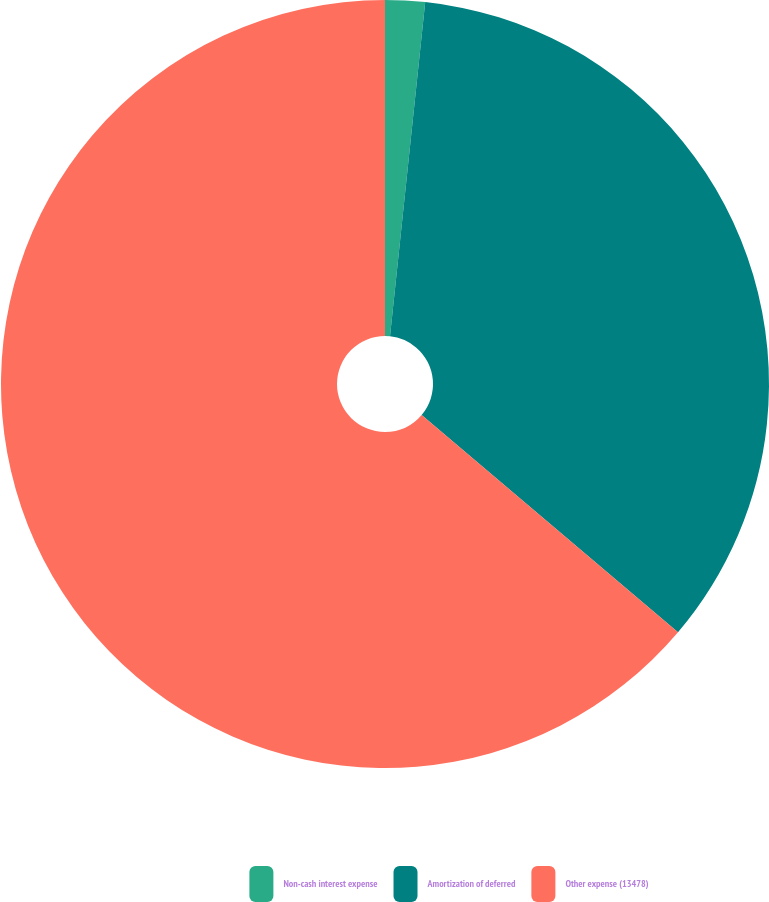<chart> <loc_0><loc_0><loc_500><loc_500><pie_chart><fcel>Non-cash interest expense<fcel>Amortization of deferred<fcel>Other expense (13478)<nl><fcel>1.67%<fcel>34.52%<fcel>63.82%<nl></chart> 